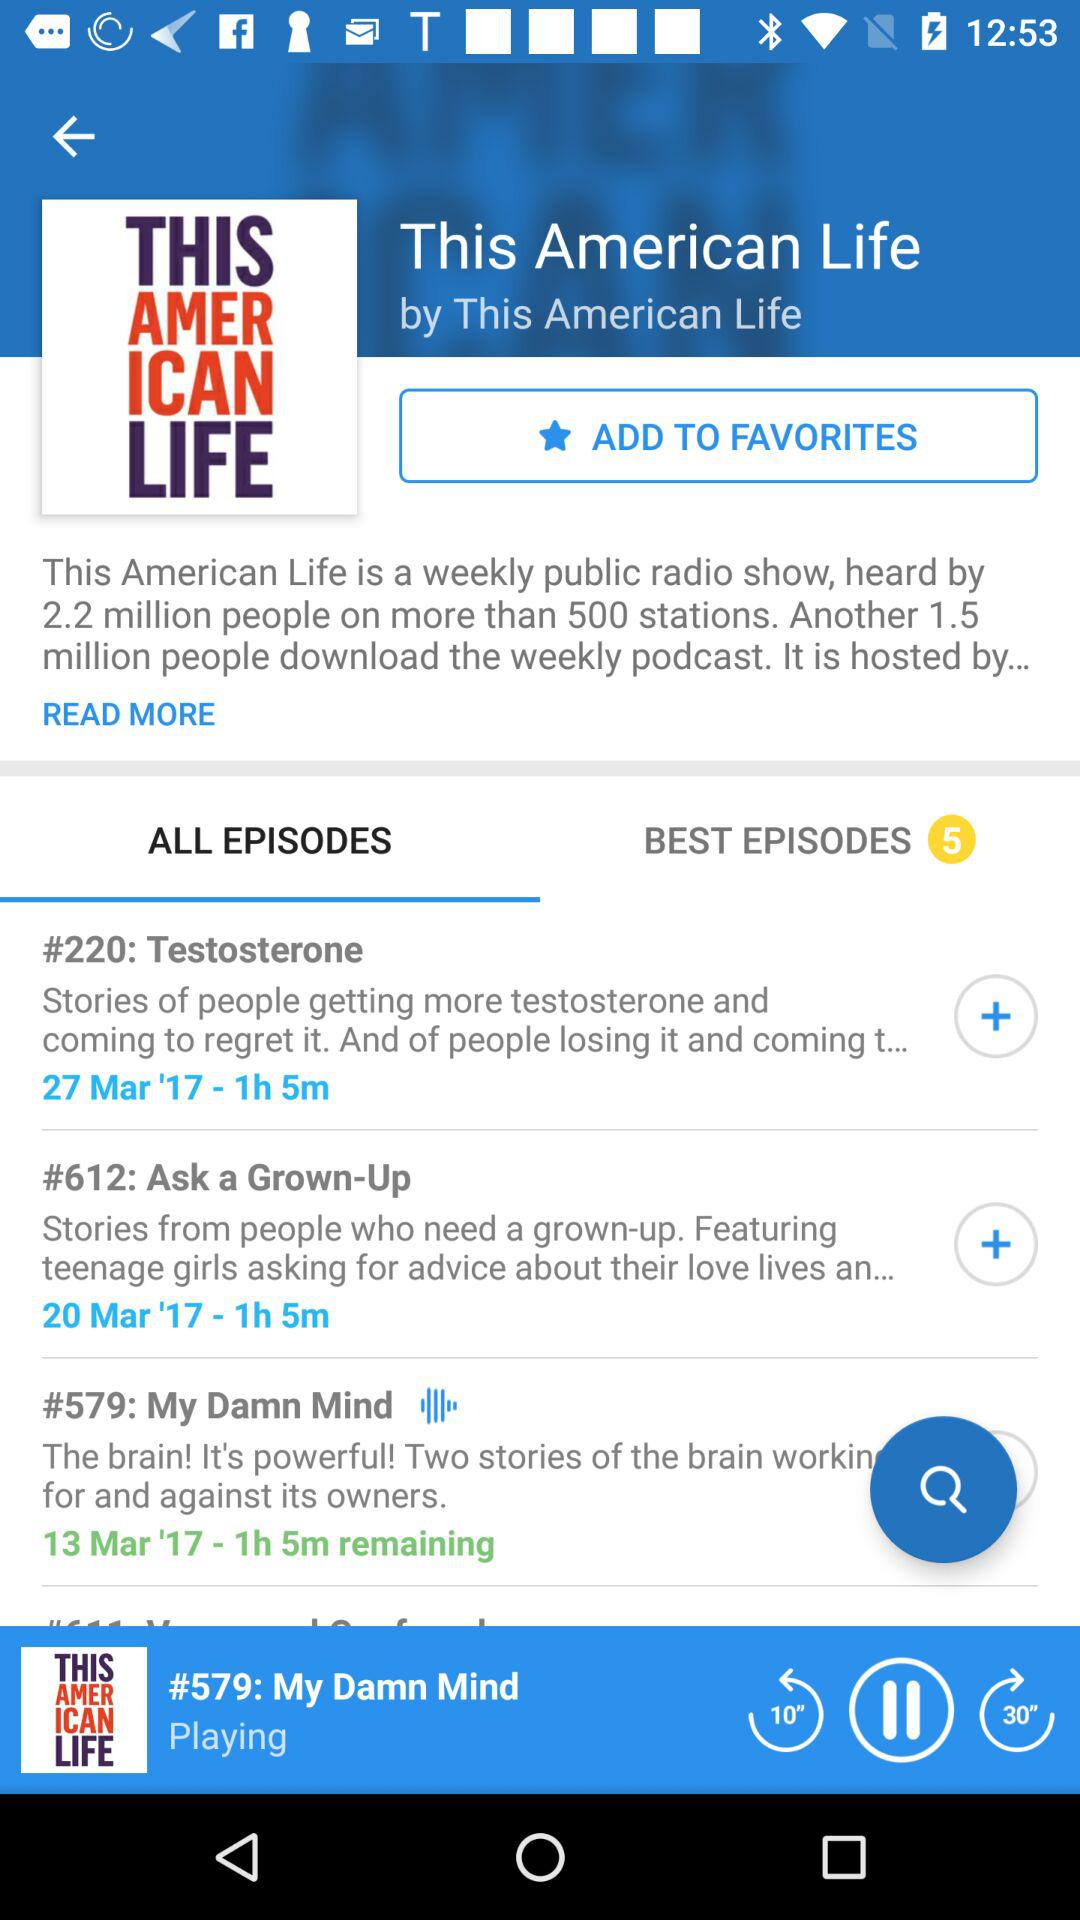What are the available episodes in "ALL EPISODES"? The available episodes in "ALL EPISODES" are "Testosterone", "Ask a Grown-Up" and "My Damn Mind". 